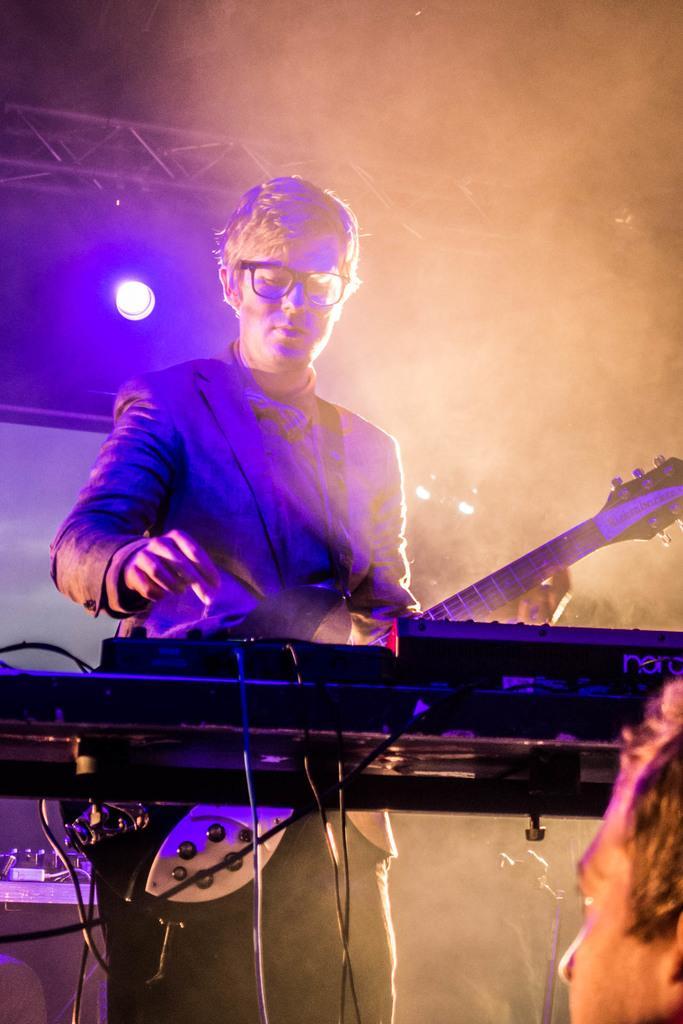Could you give a brief overview of what you see in this image? The image is taken in the music concert. In the center of the image there is a man standing, he is holding a guitar in his hand, before him there is a piano. In the background there is a light. 